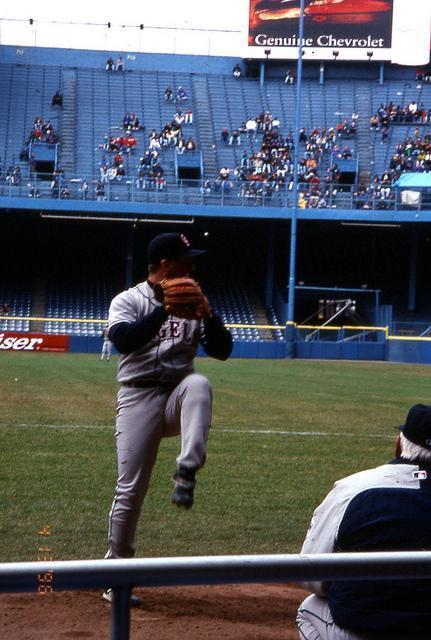How many chairs are there?
Give a very brief answer. 2. How many people are in the photo?
Give a very brief answer. 3. How many people are wearing a orange shirt?
Give a very brief answer. 0. 